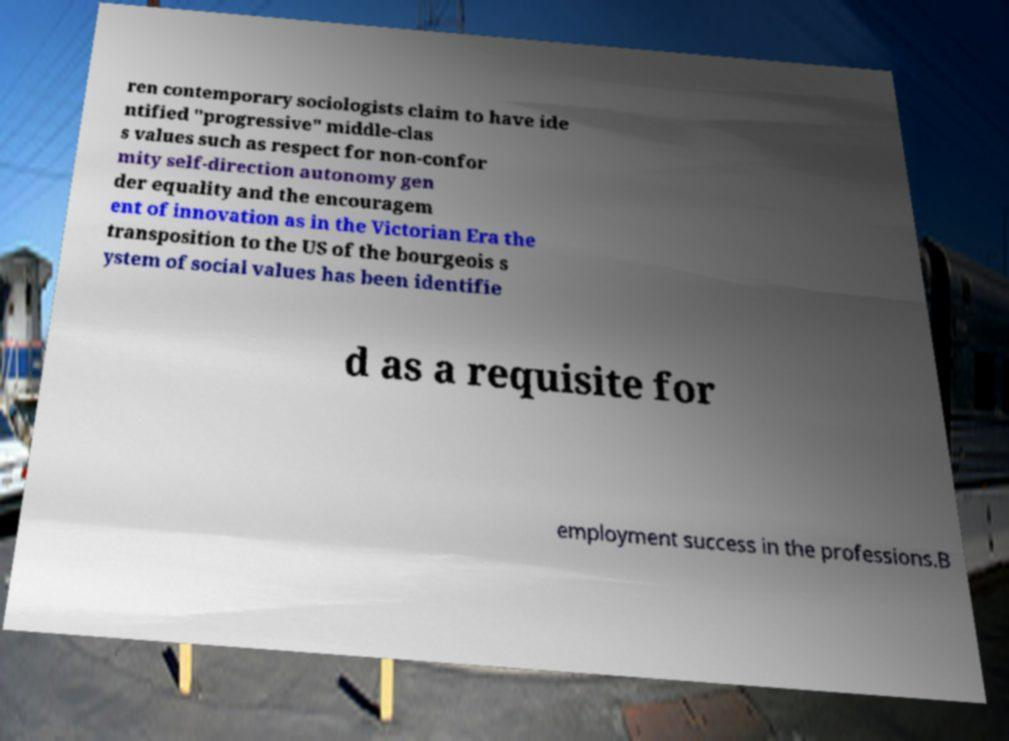There's text embedded in this image that I need extracted. Can you transcribe it verbatim? ren contemporary sociologists claim to have ide ntified "progressive" middle-clas s values such as respect for non-confor mity self-direction autonomy gen der equality and the encouragem ent of innovation as in the Victorian Era the transposition to the US of the bourgeois s ystem of social values has been identifie d as a requisite for employment success in the professions.B 